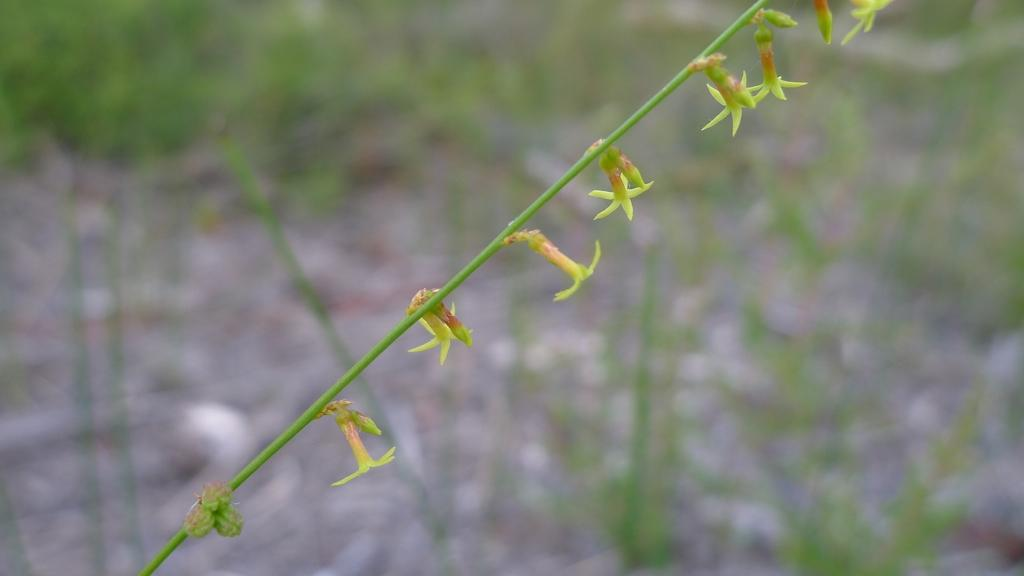What is there are any specific types of flowers in the foreground of the image? The facts provided do not specify any particular type of flowers. What is the relationship between the flowers and the creeper? The flowers are part of a creeper, which means they are growing on or along the creeper. Can you describe the background of the image? The background of the image is blurred, which suggests that the focus is on the flowers in the foreground. How many fingers can be seen touching the flowers in the image? There are no fingers or hands visible in the image; it only shows flowers and a creeper. 